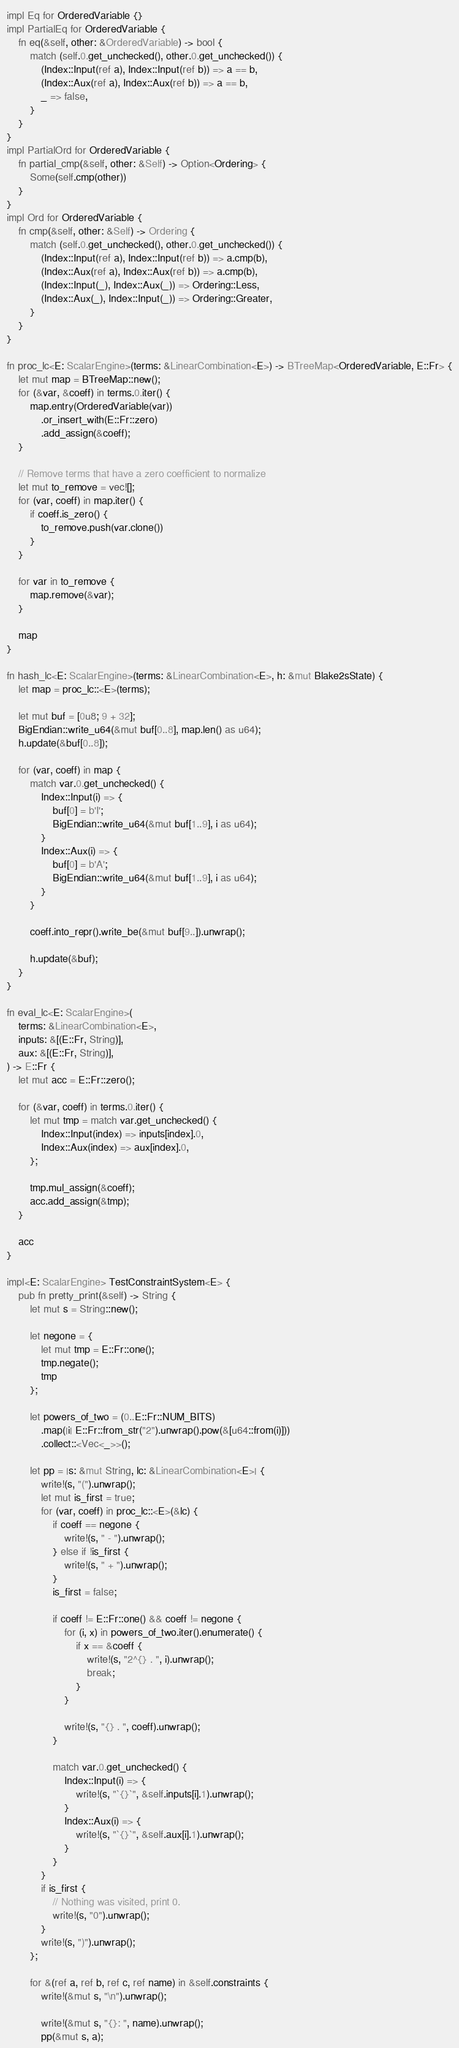Convert code to text. <code><loc_0><loc_0><loc_500><loc_500><_Rust_>
impl Eq for OrderedVariable {}
impl PartialEq for OrderedVariable {
    fn eq(&self, other: &OrderedVariable) -> bool {
        match (self.0.get_unchecked(), other.0.get_unchecked()) {
            (Index::Input(ref a), Index::Input(ref b)) => a == b,
            (Index::Aux(ref a), Index::Aux(ref b)) => a == b,
            _ => false,
        }
    }
}
impl PartialOrd for OrderedVariable {
    fn partial_cmp(&self, other: &Self) -> Option<Ordering> {
        Some(self.cmp(other))
    }
}
impl Ord for OrderedVariable {
    fn cmp(&self, other: &Self) -> Ordering {
        match (self.0.get_unchecked(), other.0.get_unchecked()) {
            (Index::Input(ref a), Index::Input(ref b)) => a.cmp(b),
            (Index::Aux(ref a), Index::Aux(ref b)) => a.cmp(b),
            (Index::Input(_), Index::Aux(_)) => Ordering::Less,
            (Index::Aux(_), Index::Input(_)) => Ordering::Greater,
        }
    }
}

fn proc_lc<E: ScalarEngine>(terms: &LinearCombination<E>) -> BTreeMap<OrderedVariable, E::Fr> {
    let mut map = BTreeMap::new();
    for (&var, &coeff) in terms.0.iter() {
        map.entry(OrderedVariable(var))
            .or_insert_with(E::Fr::zero)
            .add_assign(&coeff);
    }

    // Remove terms that have a zero coefficient to normalize
    let mut to_remove = vec![];
    for (var, coeff) in map.iter() {
        if coeff.is_zero() {
            to_remove.push(var.clone())
        }
    }

    for var in to_remove {
        map.remove(&var);
    }

    map
}

fn hash_lc<E: ScalarEngine>(terms: &LinearCombination<E>, h: &mut Blake2sState) {
    let map = proc_lc::<E>(terms);

    let mut buf = [0u8; 9 + 32];
    BigEndian::write_u64(&mut buf[0..8], map.len() as u64);
    h.update(&buf[0..8]);

    for (var, coeff) in map {
        match var.0.get_unchecked() {
            Index::Input(i) => {
                buf[0] = b'I';
                BigEndian::write_u64(&mut buf[1..9], i as u64);
            }
            Index::Aux(i) => {
                buf[0] = b'A';
                BigEndian::write_u64(&mut buf[1..9], i as u64);
            }
        }

        coeff.into_repr().write_be(&mut buf[9..]).unwrap();

        h.update(&buf);
    }
}

fn eval_lc<E: ScalarEngine>(
    terms: &LinearCombination<E>,
    inputs: &[(E::Fr, String)],
    aux: &[(E::Fr, String)],
) -> E::Fr {
    let mut acc = E::Fr::zero();

    for (&var, coeff) in terms.0.iter() {
        let mut tmp = match var.get_unchecked() {
            Index::Input(index) => inputs[index].0,
            Index::Aux(index) => aux[index].0,
        };

        tmp.mul_assign(&coeff);
        acc.add_assign(&tmp);
    }

    acc
}

impl<E: ScalarEngine> TestConstraintSystem<E> {
    pub fn pretty_print(&self) -> String {
        let mut s = String::new();

        let negone = {
            let mut tmp = E::Fr::one();
            tmp.negate();
            tmp
        };

        let powers_of_two = (0..E::Fr::NUM_BITS)
            .map(|i| E::Fr::from_str("2").unwrap().pow(&[u64::from(i)]))
            .collect::<Vec<_>>();

        let pp = |s: &mut String, lc: &LinearCombination<E>| {
            write!(s, "(").unwrap();
            let mut is_first = true;
            for (var, coeff) in proc_lc::<E>(&lc) {
                if coeff == negone {
                    write!(s, " - ").unwrap();
                } else if !is_first {
                    write!(s, " + ").unwrap();
                }
                is_first = false;

                if coeff != E::Fr::one() && coeff != negone {
                    for (i, x) in powers_of_two.iter().enumerate() {
                        if x == &coeff {
                            write!(s, "2^{} . ", i).unwrap();
                            break;
                        }
                    }

                    write!(s, "{} . ", coeff).unwrap();
                }

                match var.0.get_unchecked() {
                    Index::Input(i) => {
                        write!(s, "`{}`", &self.inputs[i].1).unwrap();
                    }
                    Index::Aux(i) => {
                        write!(s, "`{}`", &self.aux[i].1).unwrap();
                    }
                }
            }
            if is_first {
                // Nothing was visited, print 0.
                write!(s, "0").unwrap();
            }
            write!(s, ")").unwrap();
        };

        for &(ref a, ref b, ref c, ref name) in &self.constraints {
            write!(&mut s, "\n").unwrap();

            write!(&mut s, "{}: ", name).unwrap();
            pp(&mut s, a);</code> 